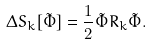Convert formula to latex. <formula><loc_0><loc_0><loc_500><loc_500>\Delta S _ { k } [ \tilde { \Phi } ] = \frac { 1 } { 2 } \tilde { \Phi } R _ { k } \tilde { \Phi } .</formula> 